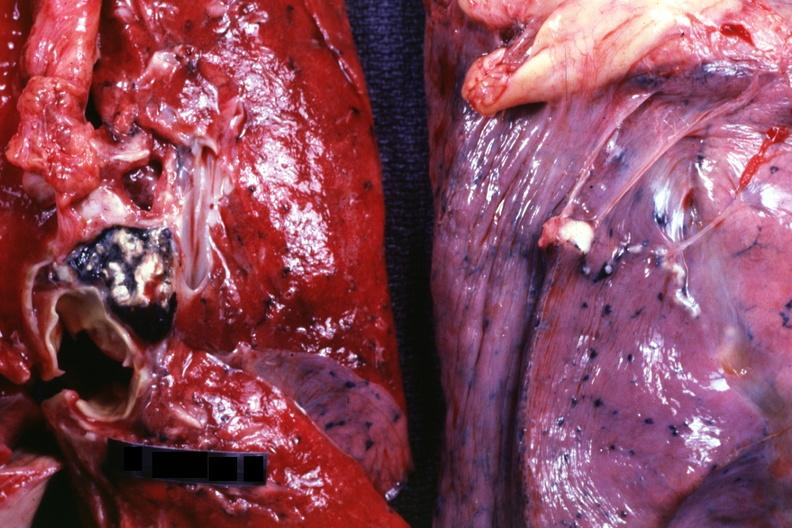what does this image show?
Answer the question using a single word or phrase. Lung and hilar node with healed and probably calcified granulomata in hilar node 